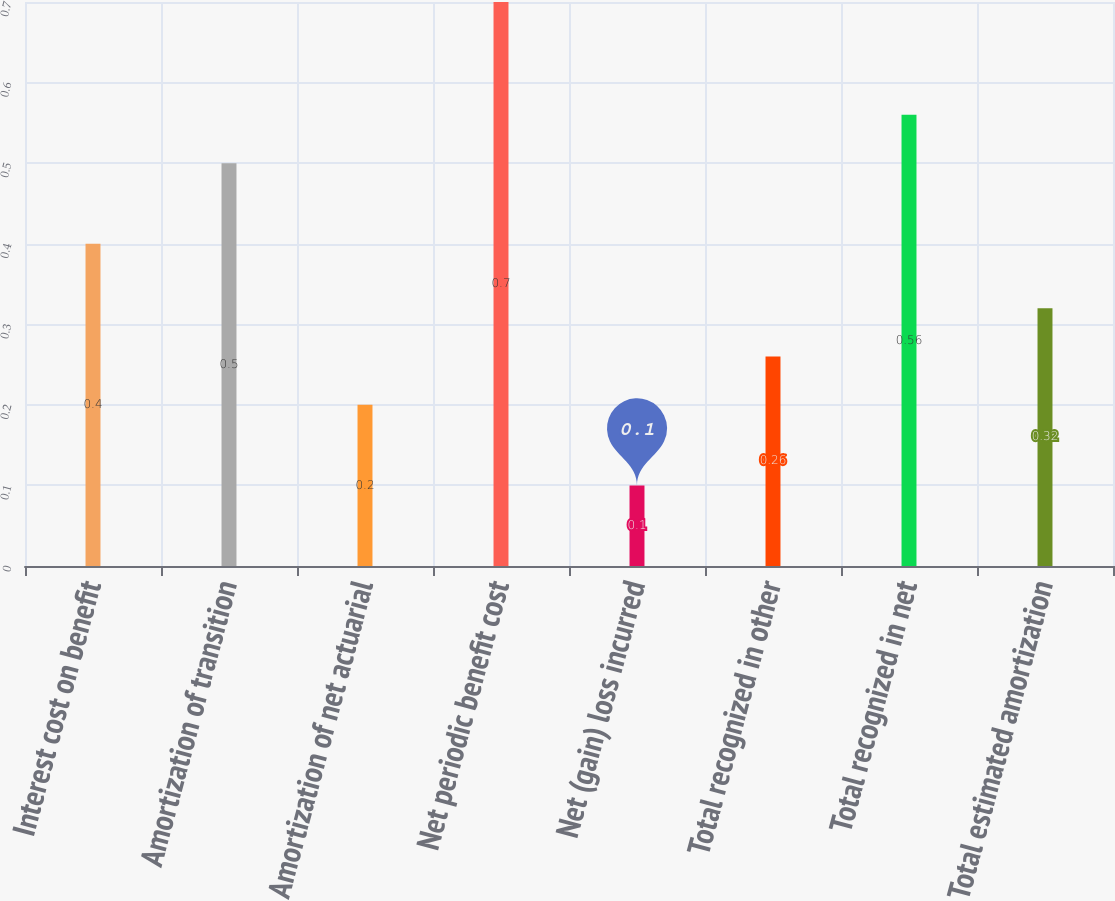<chart> <loc_0><loc_0><loc_500><loc_500><bar_chart><fcel>Interest cost on benefit<fcel>Amortization of transition<fcel>Amortization of net actuarial<fcel>Net periodic benefit cost<fcel>Net (gain) loss incurred<fcel>Total recognized in other<fcel>Total recognized in net<fcel>Total estimated amortization<nl><fcel>0.4<fcel>0.5<fcel>0.2<fcel>0.7<fcel>0.1<fcel>0.26<fcel>0.56<fcel>0.32<nl></chart> 